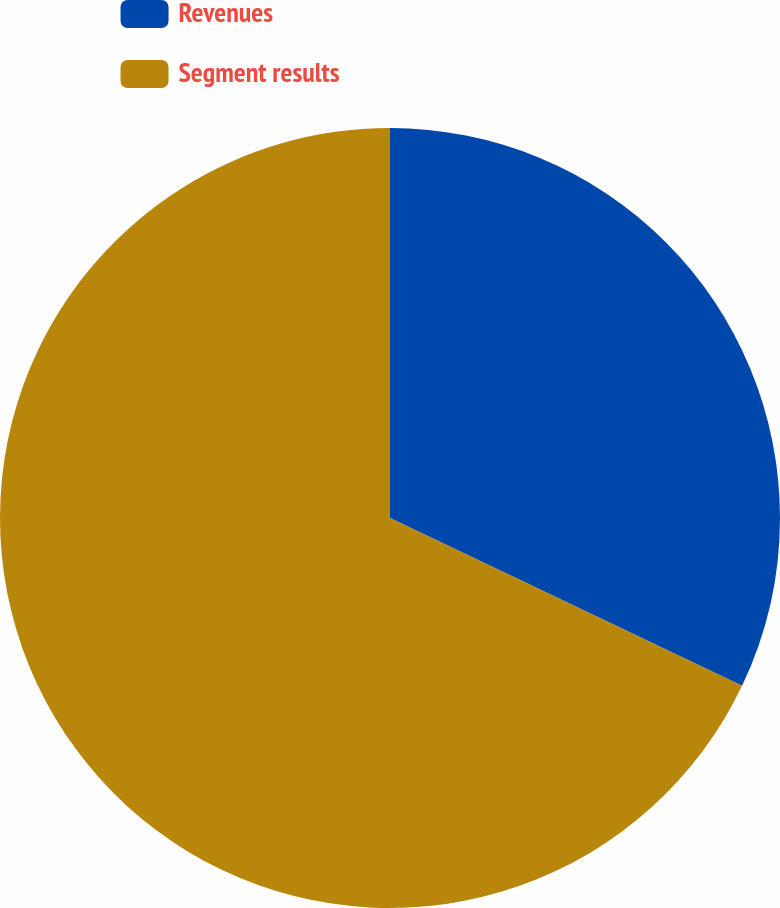Convert chart. <chart><loc_0><loc_0><loc_500><loc_500><pie_chart><fcel>Revenues<fcel>Segment results<nl><fcel>32.08%<fcel>67.92%<nl></chart> 